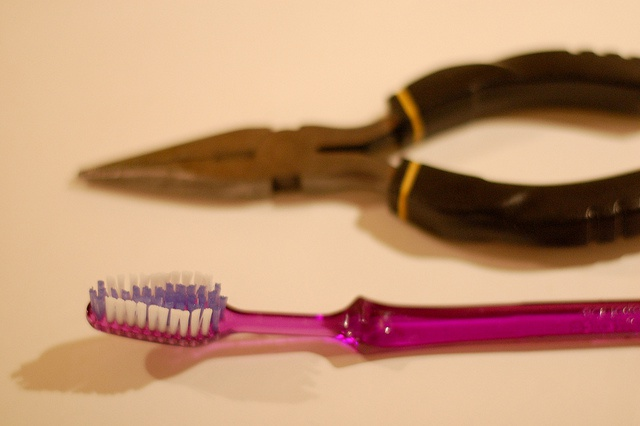Describe the objects in this image and their specific colors. I can see a toothbrush in tan, purple, brown, and maroon tones in this image. 